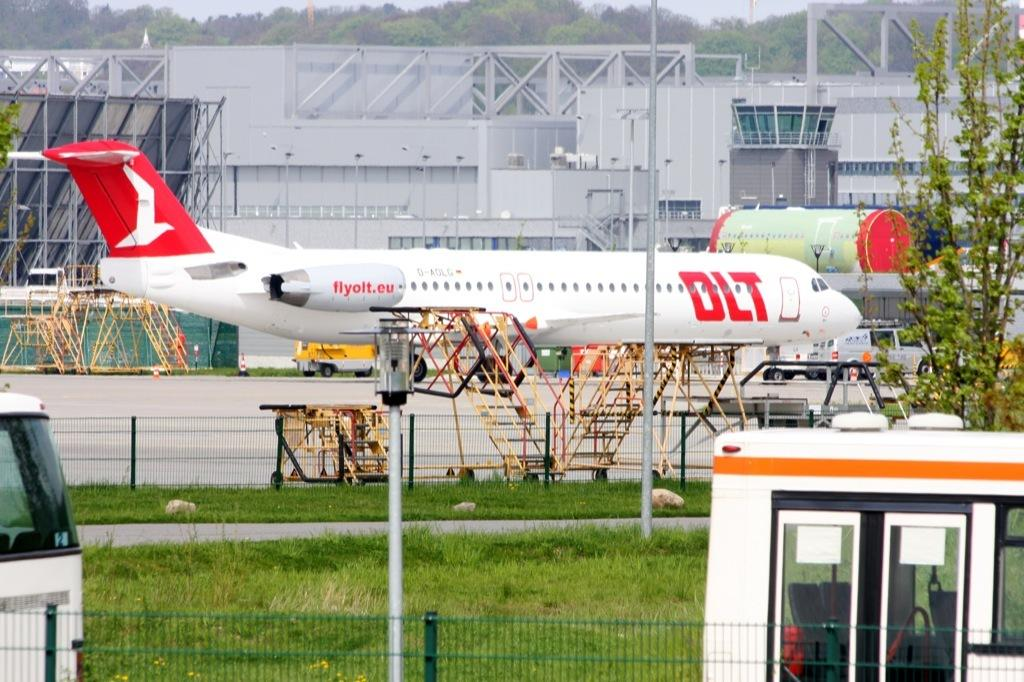<image>
Share a concise interpretation of the image provided. A DLT airplane parked on the ground, surrounded by movable stairs. 